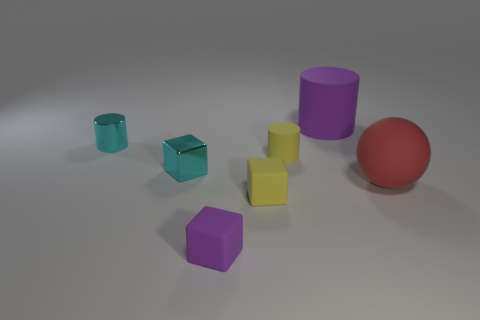Subtract all yellow cylinders. Subtract all blue cubes. How many cylinders are left? 2 Add 1 small yellow metallic spheres. How many objects exist? 8 Subtract all spheres. How many objects are left? 6 Subtract all red balls. Subtract all purple cylinders. How many objects are left? 5 Add 2 big purple matte cylinders. How many big purple matte cylinders are left? 3 Add 6 red spheres. How many red spheres exist? 7 Subtract 1 cyan blocks. How many objects are left? 6 